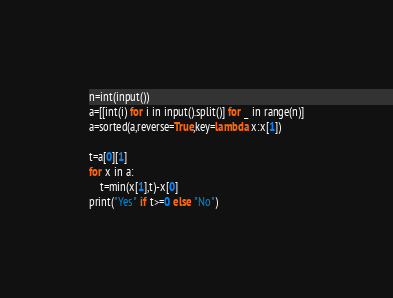Convert code to text. <code><loc_0><loc_0><loc_500><loc_500><_Python_>n=int(input())
a=[[int(i) for i in input().split()] for _ in range(n)]
a=sorted(a,reverse=True,key=lambda x:x[1])

t=a[0][1]
for x in a:
    t=min(x[1],t)-x[0]
print("Yes" if t>=0 else "No")</code> 